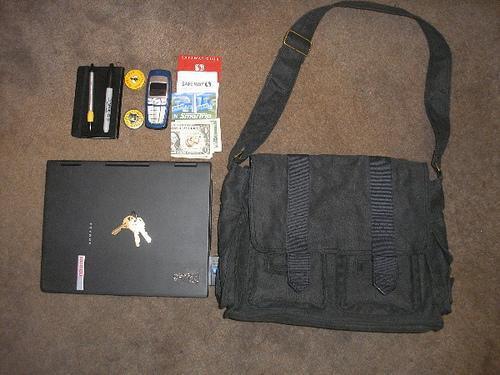How many keys are on the laptop?
Give a very brief answer. 3. How many handbags are visible?
Give a very brief answer. 1. How many zebras are there?
Give a very brief answer. 0. 